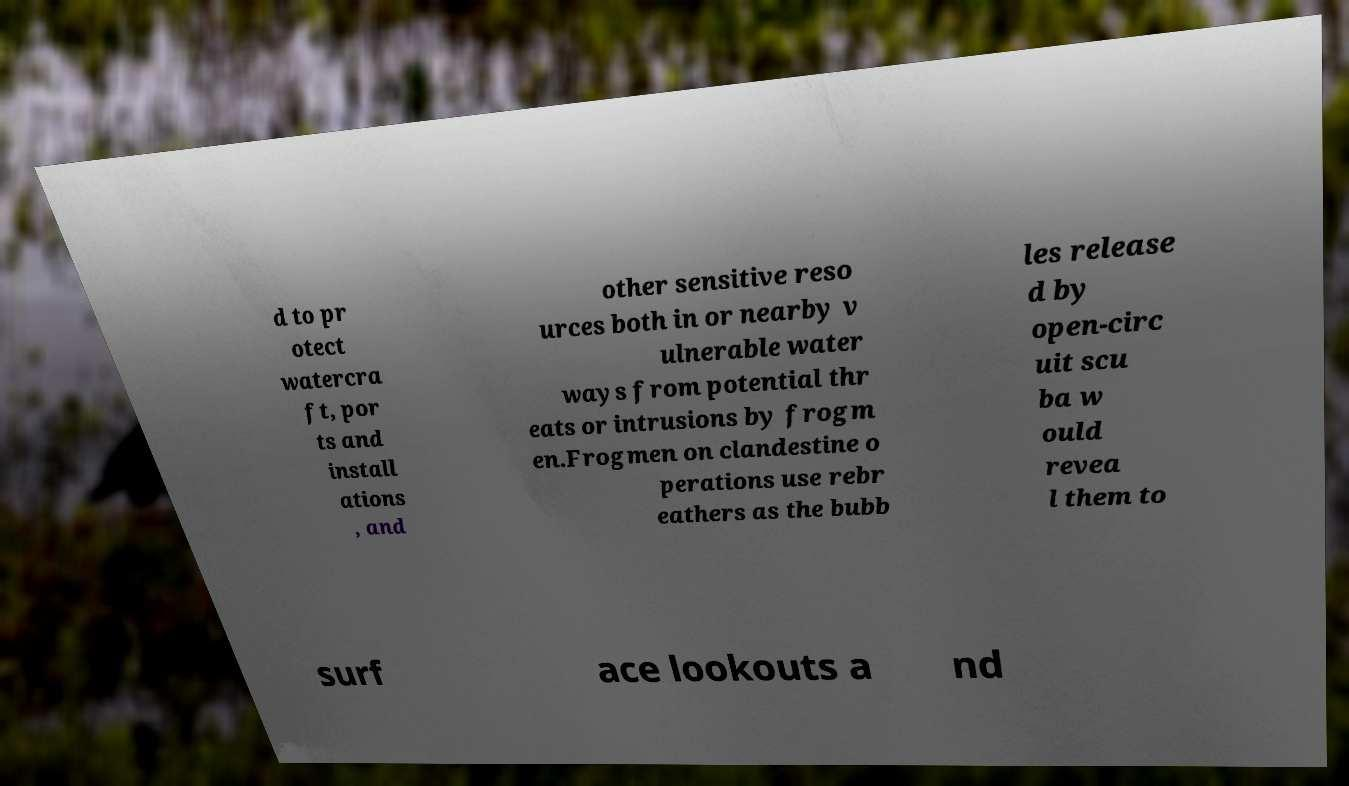Please identify and transcribe the text found in this image. d to pr otect watercra ft, por ts and install ations , and other sensitive reso urces both in or nearby v ulnerable water ways from potential thr eats or intrusions by frogm en.Frogmen on clandestine o perations use rebr eathers as the bubb les release d by open-circ uit scu ba w ould revea l them to surf ace lookouts a nd 